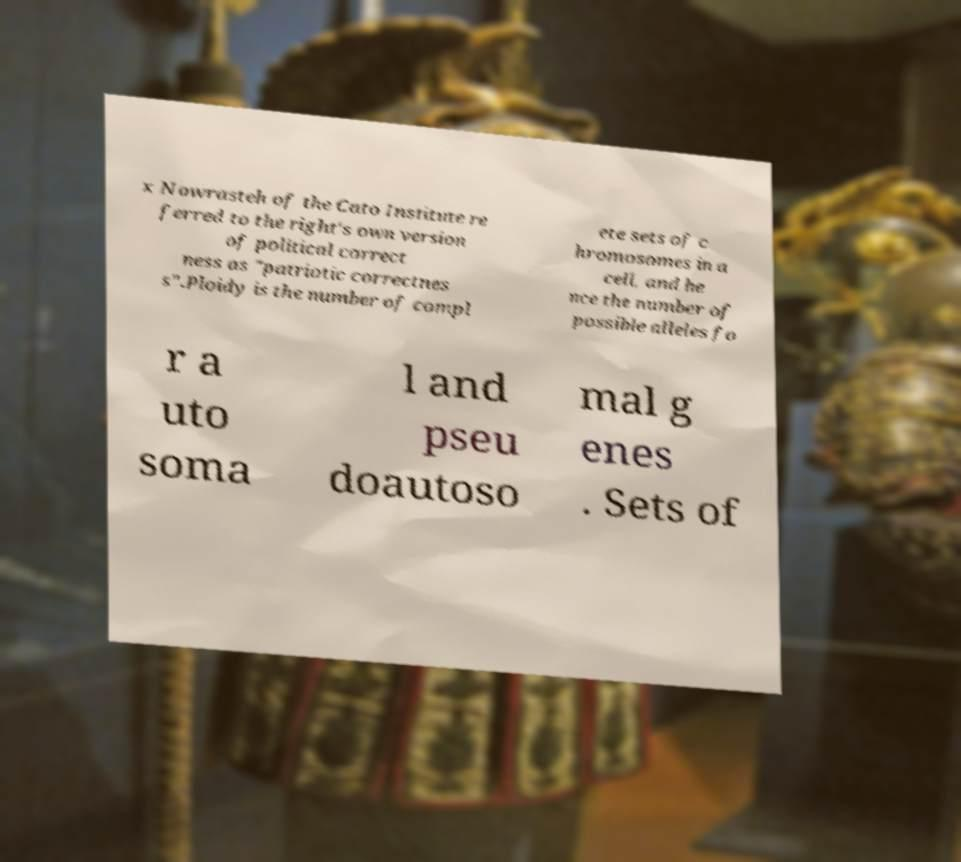Can you read and provide the text displayed in the image?This photo seems to have some interesting text. Can you extract and type it out for me? x Nowrasteh of the Cato Institute re ferred to the right's own version of political correct ness as "patriotic correctnes s".Ploidy is the number of compl ete sets of c hromosomes in a cell, and he nce the number of possible alleles fo r a uto soma l and pseu doautoso mal g enes . Sets of 